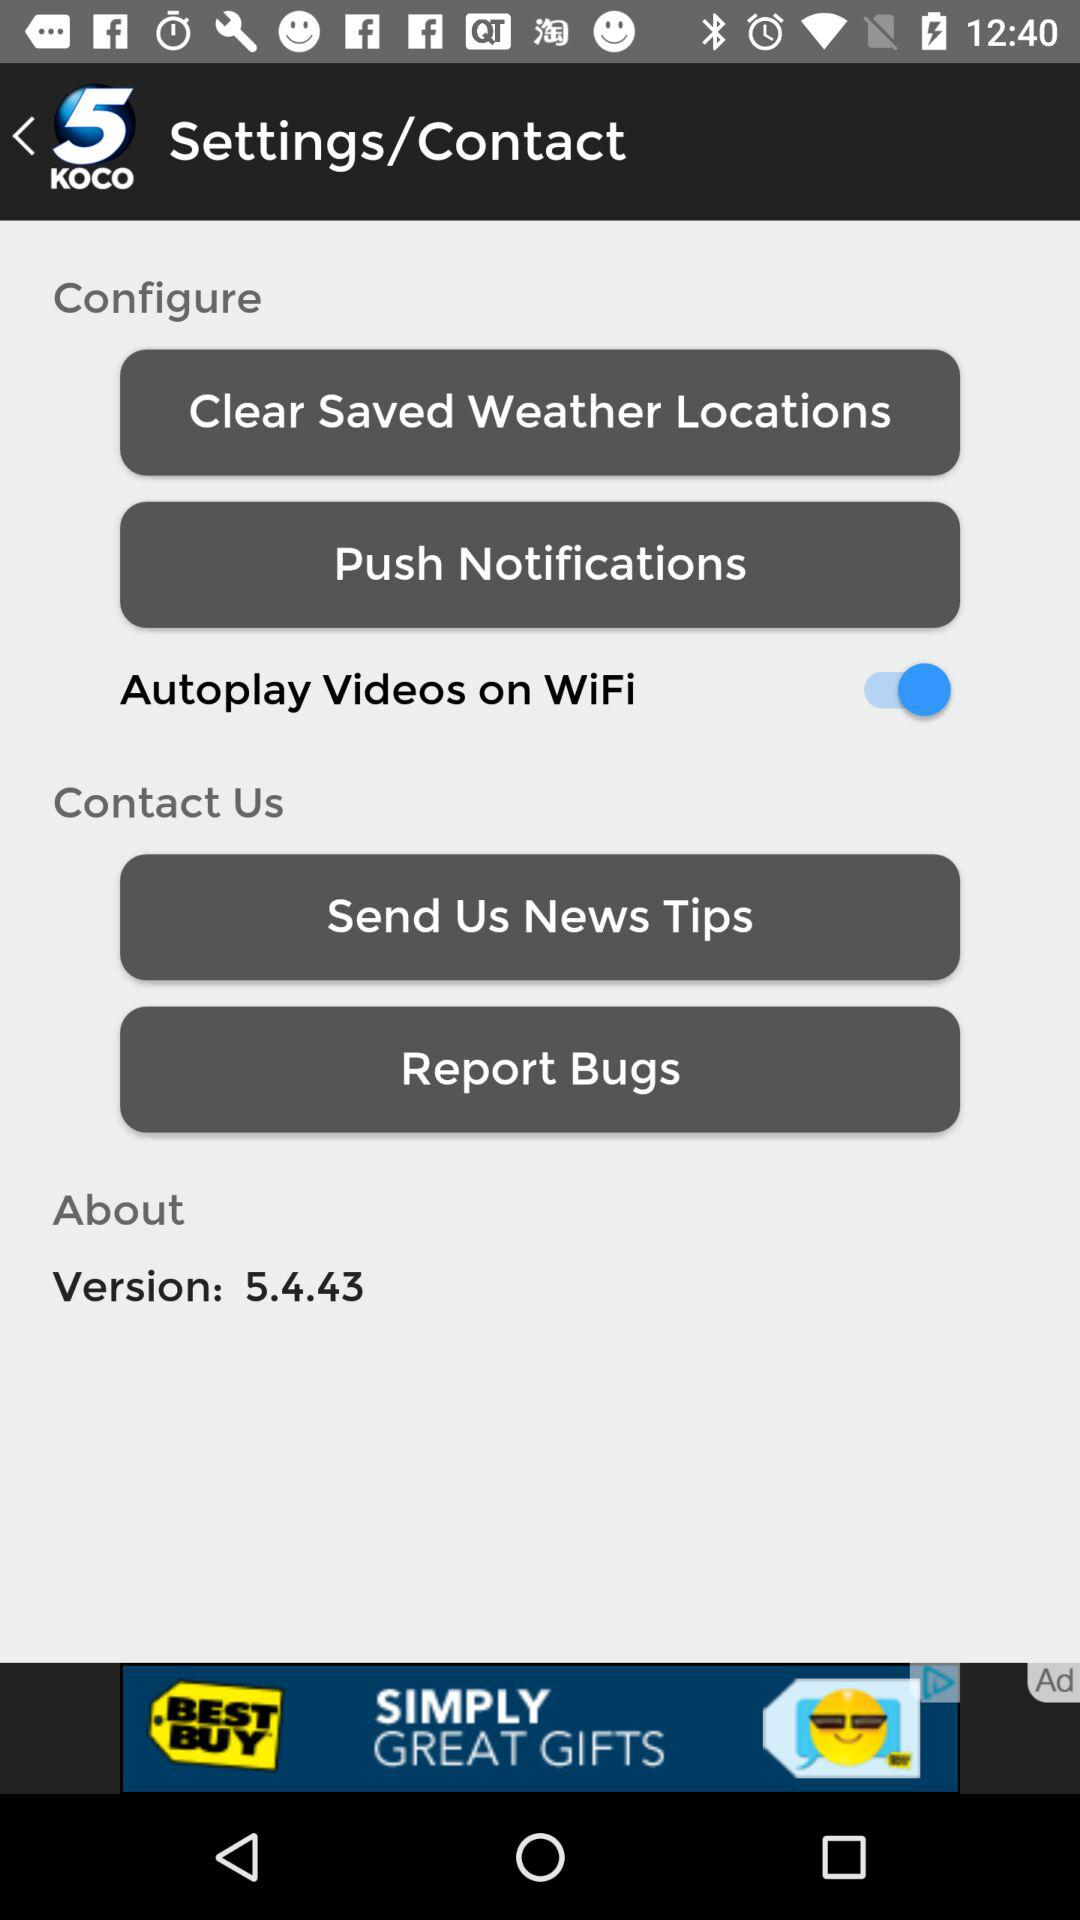What's the status of "Autoplay Videos on WiFi"? The status is "on". 